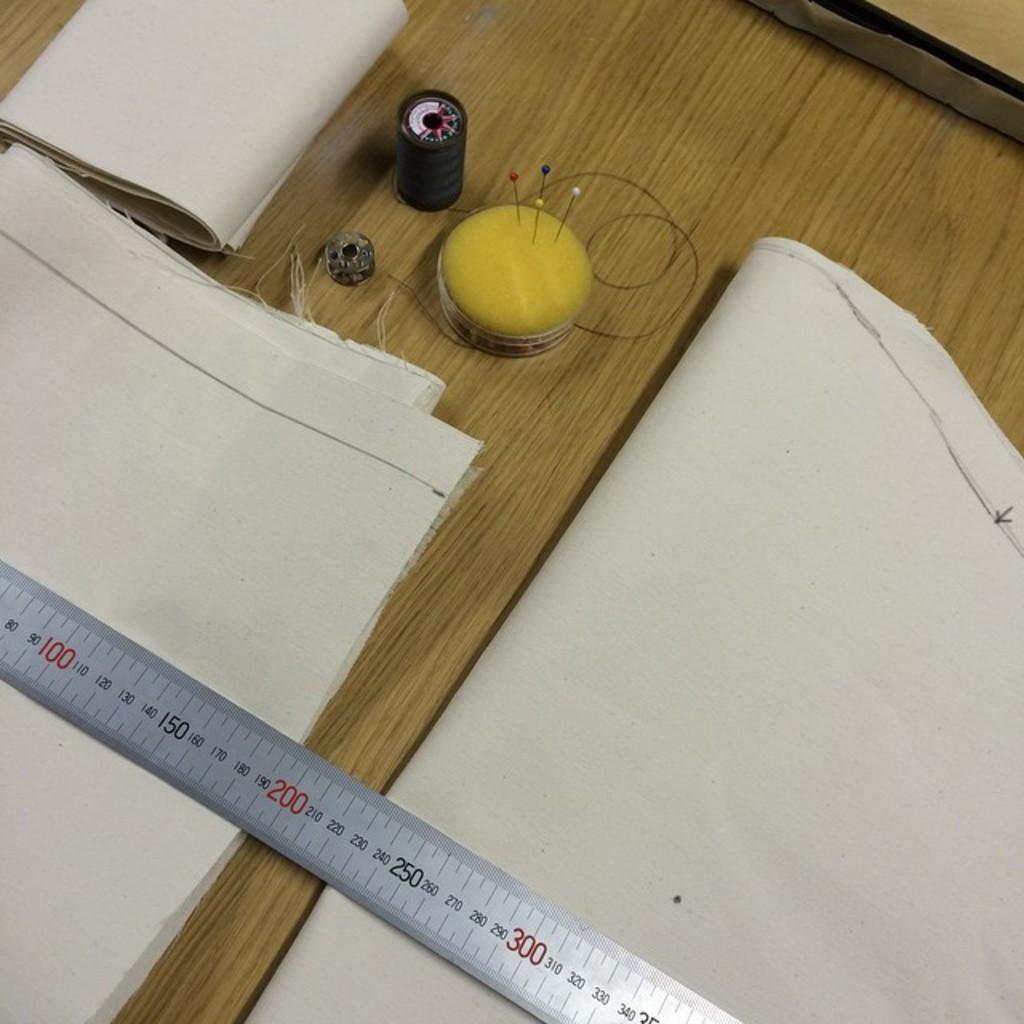<image>
Summarize the visual content of the image. A pincushion and cloth are next to a ruler running from 80 to 340. 